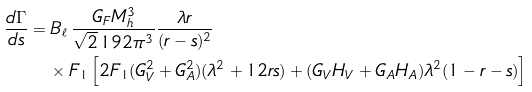Convert formula to latex. <formula><loc_0><loc_0><loc_500><loc_500>\frac { d \Gamma } { d s } & = B _ { \ell } \, \frac { G _ { F } M ^ { 3 } _ { h } } { \sqrt { 2 } \, 1 9 2 \pi ^ { 3 } } \frac { \lambda r } { ( r - s ) ^ { 2 } } \\ & \quad \times F _ { 1 } \left [ 2 F _ { 1 } ( G ^ { 2 } _ { V } + G ^ { 2 } _ { A } ) ( \lambda ^ { 2 } + 1 2 r s ) + ( G _ { V } H _ { V } + G _ { A } H _ { A } ) \lambda ^ { 2 } ( 1 - r - s ) \right ]</formula> 